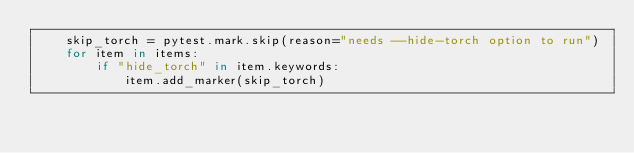<code> <loc_0><loc_0><loc_500><loc_500><_Python_>    skip_torch = pytest.mark.skip(reason="needs --hide-torch option to run")
    for item in items:
        if "hide_torch" in item.keywords:
            item.add_marker(skip_torch)
</code> 